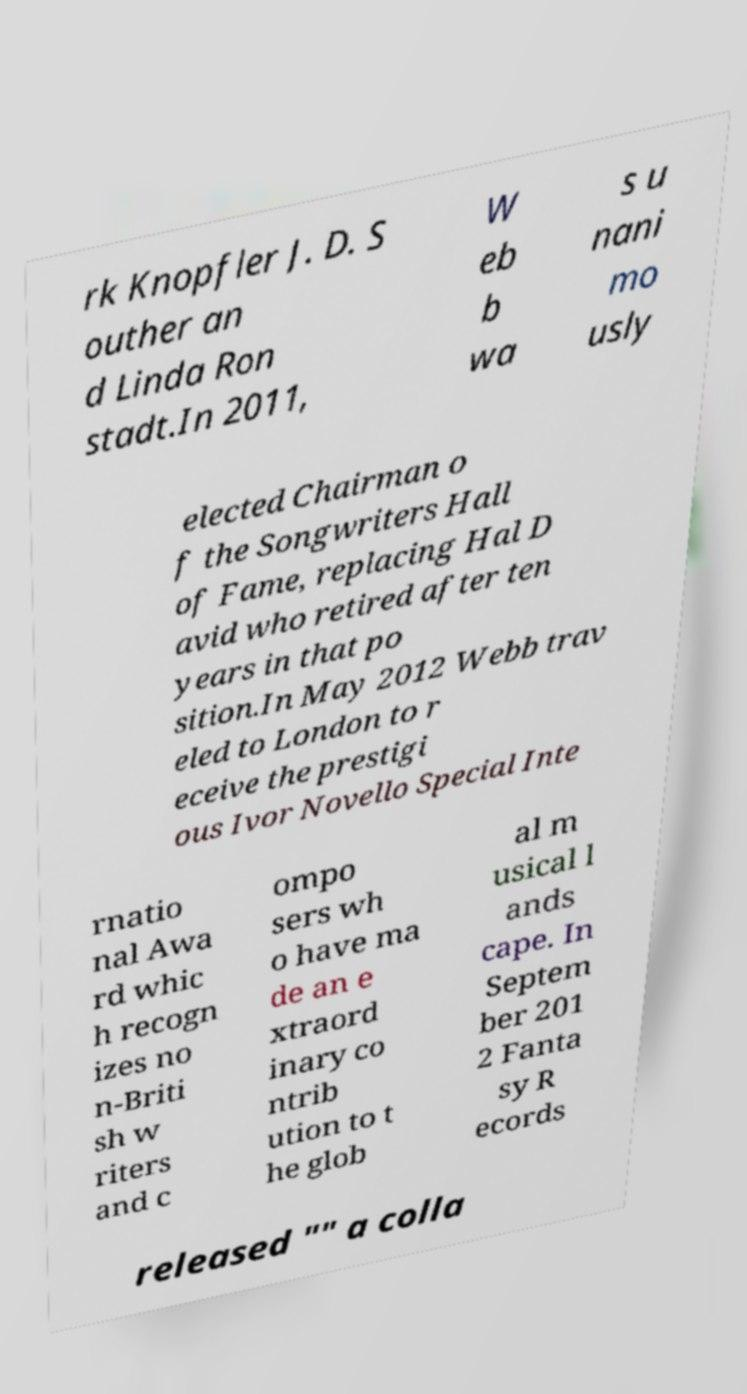Could you extract and type out the text from this image? rk Knopfler J. D. S outher an d Linda Ron stadt.In 2011, W eb b wa s u nani mo usly elected Chairman o f the Songwriters Hall of Fame, replacing Hal D avid who retired after ten years in that po sition.In May 2012 Webb trav eled to London to r eceive the prestigi ous Ivor Novello Special Inte rnatio nal Awa rd whic h recogn izes no n-Briti sh w riters and c ompo sers wh o have ma de an e xtraord inary co ntrib ution to t he glob al m usical l ands cape. In Septem ber 201 2 Fanta sy R ecords released "" a colla 